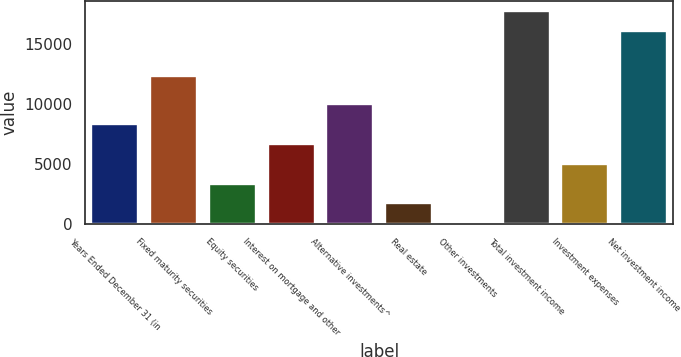Convert chart. <chart><loc_0><loc_0><loc_500><loc_500><bar_chart><fcel>Years Ended December 31 (in<fcel>Fixed maturity securities<fcel>Equity securities<fcel>Interest on mortgage and other<fcel>Alternative investments^<fcel>Real estate<fcel>Other investments<fcel>Total investment income<fcel>Investment expenses<fcel>Net investment income<nl><fcel>8321.5<fcel>12322<fcel>3356.8<fcel>6666.6<fcel>9976.4<fcel>1701.9<fcel>47<fcel>17733.9<fcel>5011.7<fcel>16079<nl></chart> 